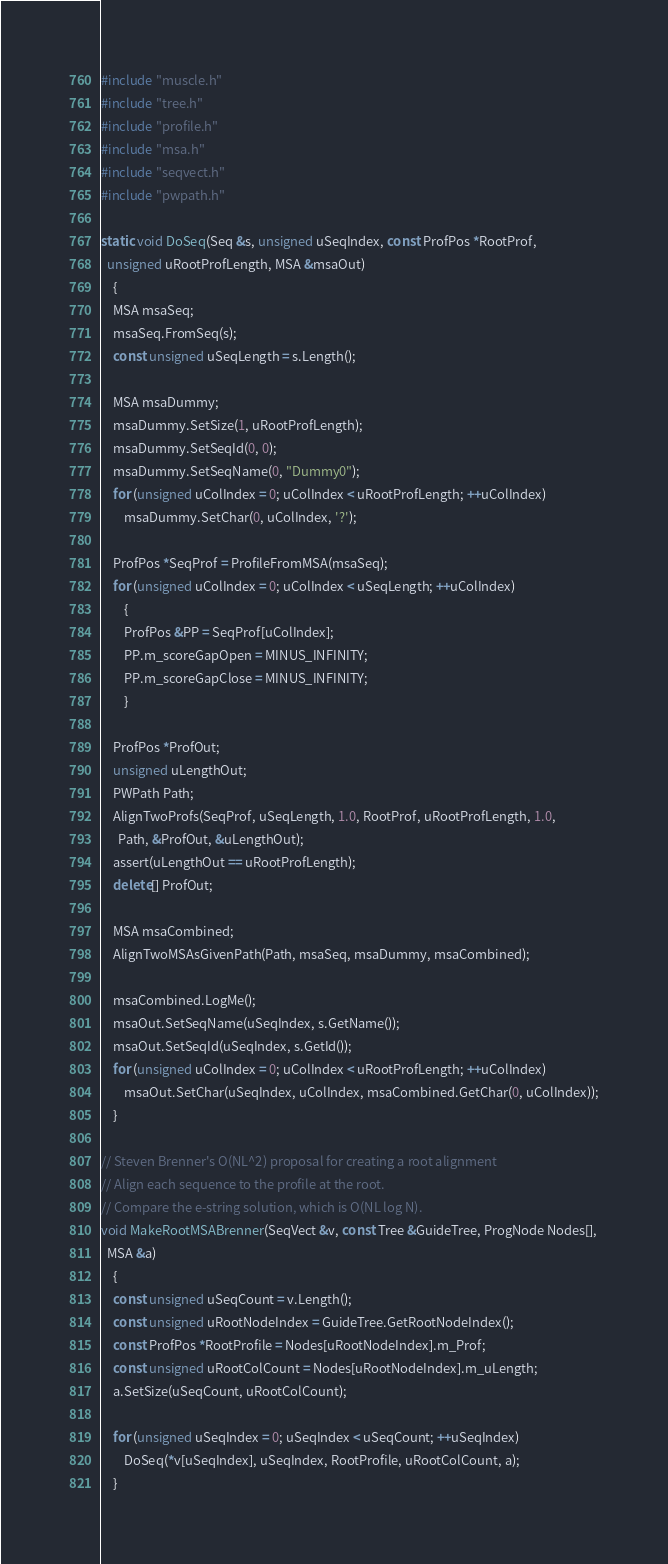Convert code to text. <code><loc_0><loc_0><loc_500><loc_500><_C++_>#include "muscle.h"
#include "tree.h"
#include "profile.h"
#include "msa.h"
#include "seqvect.h"
#include "pwpath.h"

static void DoSeq(Seq &s, unsigned uSeqIndex, const ProfPos *RootProf,
  unsigned uRootProfLength, MSA &msaOut)
	{
	MSA msaSeq;
	msaSeq.FromSeq(s);
	const unsigned uSeqLength = s.Length();

	MSA msaDummy;
	msaDummy.SetSize(1, uRootProfLength);
	msaDummy.SetSeqId(0, 0);
	msaDummy.SetSeqName(0, "Dummy0");
	for (unsigned uColIndex = 0; uColIndex < uRootProfLength; ++uColIndex)
		msaDummy.SetChar(0, uColIndex, '?');

	ProfPos *SeqProf = ProfileFromMSA(msaSeq);
	for (unsigned uColIndex = 0; uColIndex < uSeqLength; ++uColIndex)
		{
		ProfPos &PP = SeqProf[uColIndex];
		PP.m_scoreGapOpen = MINUS_INFINITY;
		PP.m_scoreGapClose = MINUS_INFINITY;
		}

	ProfPos *ProfOut;
	unsigned uLengthOut;
	PWPath Path;
	AlignTwoProfs(SeqProf, uSeqLength, 1.0, RootProf, uRootProfLength, 1.0,
	  Path, &ProfOut, &uLengthOut);
    assert(uLengthOut == uRootProfLength);
	delete[] ProfOut;

	MSA msaCombined;
	AlignTwoMSAsGivenPath(Path, msaSeq, msaDummy, msaCombined);

	msaCombined.LogMe();
	msaOut.SetSeqName(uSeqIndex, s.GetName());
	msaOut.SetSeqId(uSeqIndex, s.GetId());
	for (unsigned uColIndex = 0; uColIndex < uRootProfLength; ++uColIndex)
		msaOut.SetChar(uSeqIndex, uColIndex, msaCombined.GetChar(0, uColIndex));
	}

// Steven Brenner's O(NL^2) proposal for creating a root alignment
// Align each sequence to the profile at the root.
// Compare the e-string solution, which is O(NL log N).
void MakeRootMSABrenner(SeqVect &v, const Tree &GuideTree, ProgNode Nodes[],
  MSA &a)
	{
	const unsigned uSeqCount = v.Length();
	const unsigned uRootNodeIndex = GuideTree.GetRootNodeIndex();
	const ProfPos *RootProfile = Nodes[uRootNodeIndex].m_Prof;
	const unsigned uRootColCount = Nodes[uRootNodeIndex].m_uLength;
	a.SetSize(uSeqCount, uRootColCount);

	for (unsigned uSeqIndex = 0; uSeqIndex < uSeqCount; ++uSeqIndex)
		DoSeq(*v[uSeqIndex], uSeqIndex, RootProfile, uRootColCount, a);
	}
</code> 